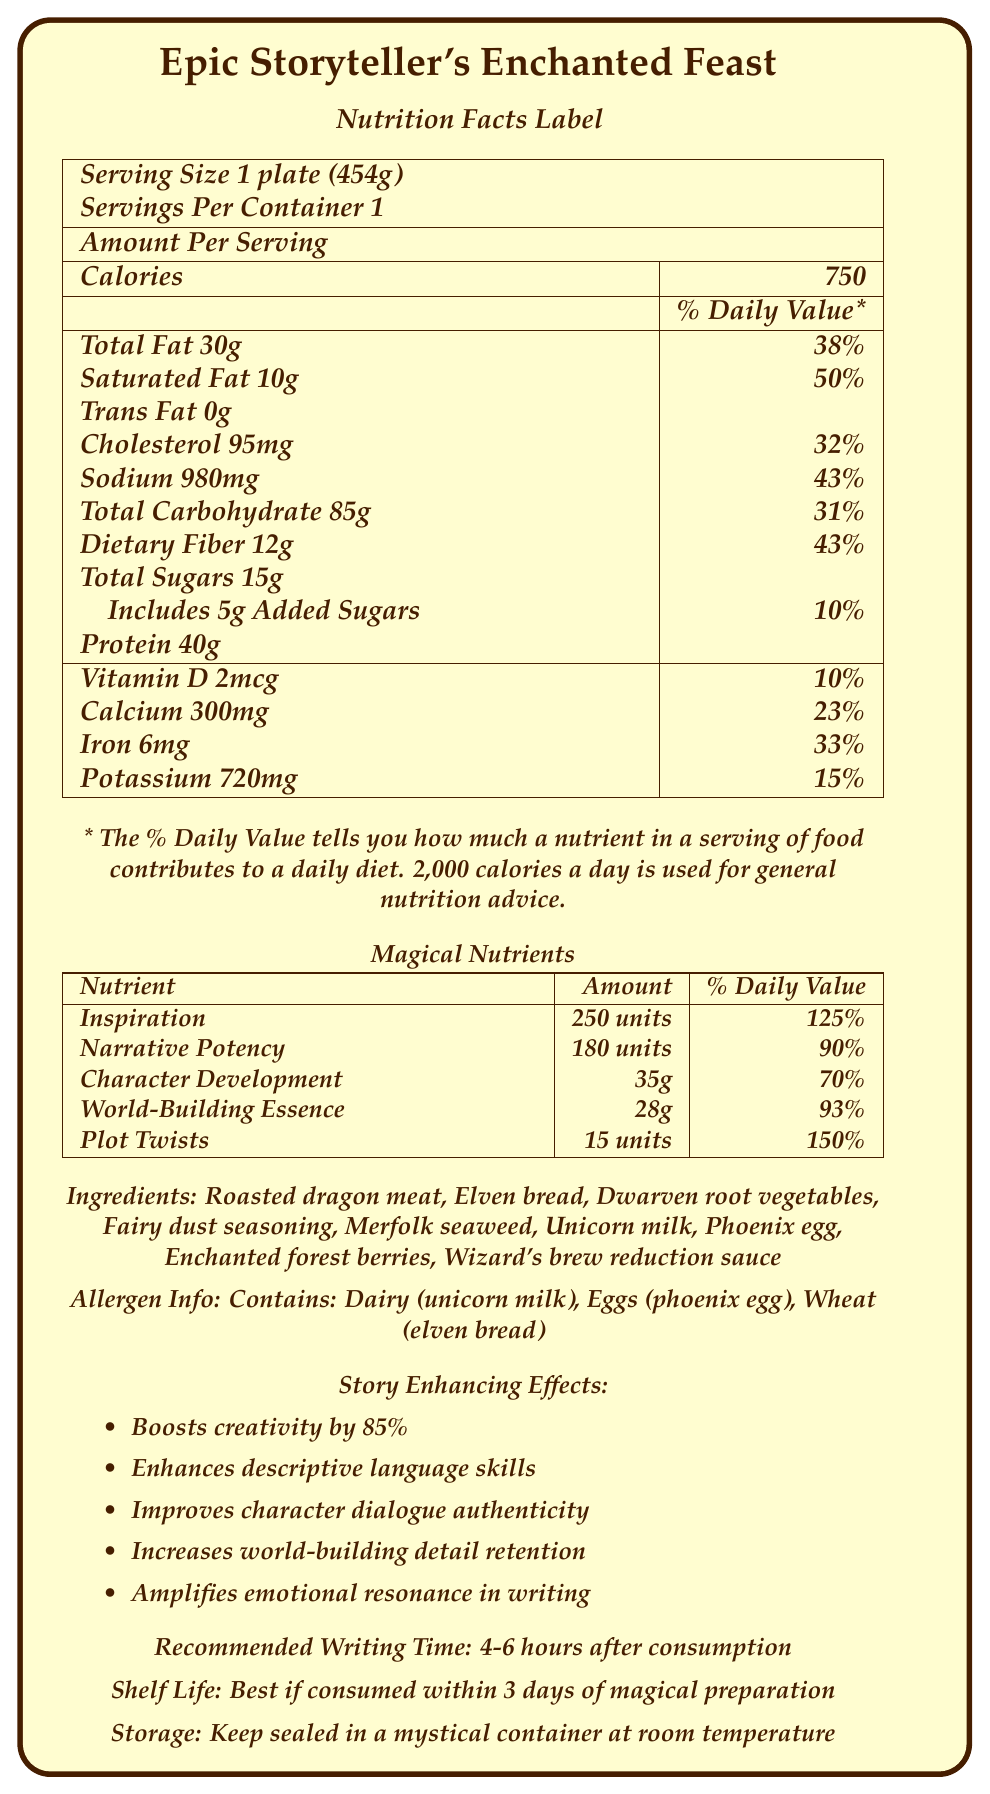what is the serving size of Epic Storyteller's Enchanted Feast? The serving size is clearly labeled under the "Nutrition Facts Label" section. It states "Serving Size 1 plate (454g)".
Answer: 1 plate (454g) what are the ingredients in the Enchanted Feast? The ingredients are listed in a section titled "Ingredients".
Answer: Roasted dragon meat, Elven bread, Dwarven root vegetables, Fairy dust seasoning, Merfolk seaweed, Unicorn milk, Phoenix egg, Enchanted forest berries, Wizard's brew reduction sauce how many calories does one serving of the Enchanted Feast contain? The calorie count is displayed prominently under the "Amount Per Serving" section in the nutrition facts.
Answer: 750 what is the daily value percentage for total fat? The daily value percentage for total fat is listed under "Total Fat" in the nutrition facts as 38%.
Answer: 38% how long after consumption is the recommended writing time? The "Recommended Writing Time" section specifies that the ideal writing time is 4-6 hours after consumption.
Answer: 4-6 hours what is the amount of inspiration units provided per serving? In the "Magical Nutrients" section, inspiration is listed with an amount of 250 units per serving.
Answer: 250 units what is the daily value percentage for plot twists? The daily value percentage for plot twists is noted in the "Magical Nutrients" section as 150%.
Answer: 150% which of the following is NOT an ingredient in the Enchanted Feast? A. Unicorn milk B. Phoenix egg C. Goblin herbs D. Merfolk seaweed Goblin herbs are not listed among the ingredients in the Enchanted Feast.
Answer: C which essential nutrient has the highest daily value percentage? A. Iron B. Calcium C. Vitamin D D. Potassium Iron has the highest daily value percentage among the listed essential nutrients with 33%.
Answer: A does this product contain any allergens? The allergen information states it contains dairy (unicorn milk), eggs (phoenix egg), and wheat (elven bread).
Answer: Yes describe the intended effects of consuming the Enchanted Feast on storytelling abilities. The document outlines the story-enhancing effects in a dedicated section "Story Enhancing Effects".
Answer: The Enchanted Feast boosts creativity by 85%, enhances descriptive language skills, improves character dialogue authenticity, increases world-building detail retention, and amplifies emotional resonance in writing. what is the shelf life of the Enchanted Feast? The "Shelf Life" section clarifies that the feast is best consumed within 3 days of its preparation.
Answer: Best if consumed within 3 days of magical preparation what percentage of daily value does the sodium content provide? The sodium content provides 43% of the daily value as mentioned in the nutrition facts.
Answer: 43% do we know the exact recipe or preparation method for the Enchanted Feast? The document lists ingredients but does not provide the specific recipe or preparation method for the Enchanted Feast.
Answer: Not enough information 